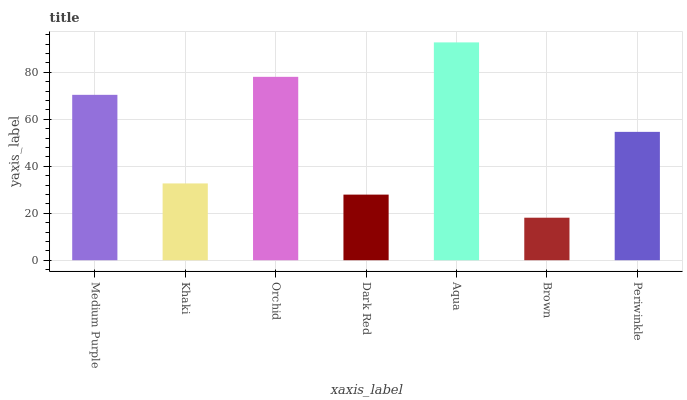Is Khaki the minimum?
Answer yes or no. No. Is Khaki the maximum?
Answer yes or no. No. Is Medium Purple greater than Khaki?
Answer yes or no. Yes. Is Khaki less than Medium Purple?
Answer yes or no. Yes. Is Khaki greater than Medium Purple?
Answer yes or no. No. Is Medium Purple less than Khaki?
Answer yes or no. No. Is Periwinkle the high median?
Answer yes or no. Yes. Is Periwinkle the low median?
Answer yes or no. Yes. Is Khaki the high median?
Answer yes or no. No. Is Khaki the low median?
Answer yes or no. No. 